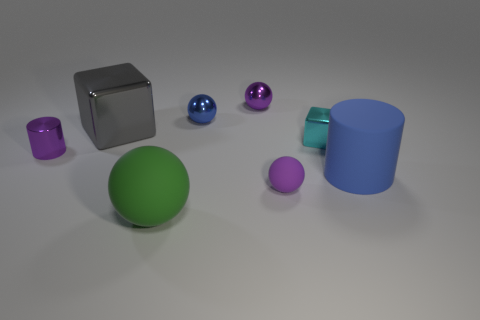Subtract all large spheres. How many spheres are left? 3 Add 1 big red rubber things. How many objects exist? 9 Subtract 1 spheres. How many spheres are left? 3 Subtract all cylinders. How many objects are left? 6 Subtract all red spheres. Subtract all green cylinders. How many spheres are left? 4 Subtract all large gray metallic cubes. Subtract all big matte cubes. How many objects are left? 7 Add 2 large shiny things. How many large shiny things are left? 3 Add 4 big brown metallic cylinders. How many big brown metallic cylinders exist? 4 Subtract 0 yellow cubes. How many objects are left? 8 